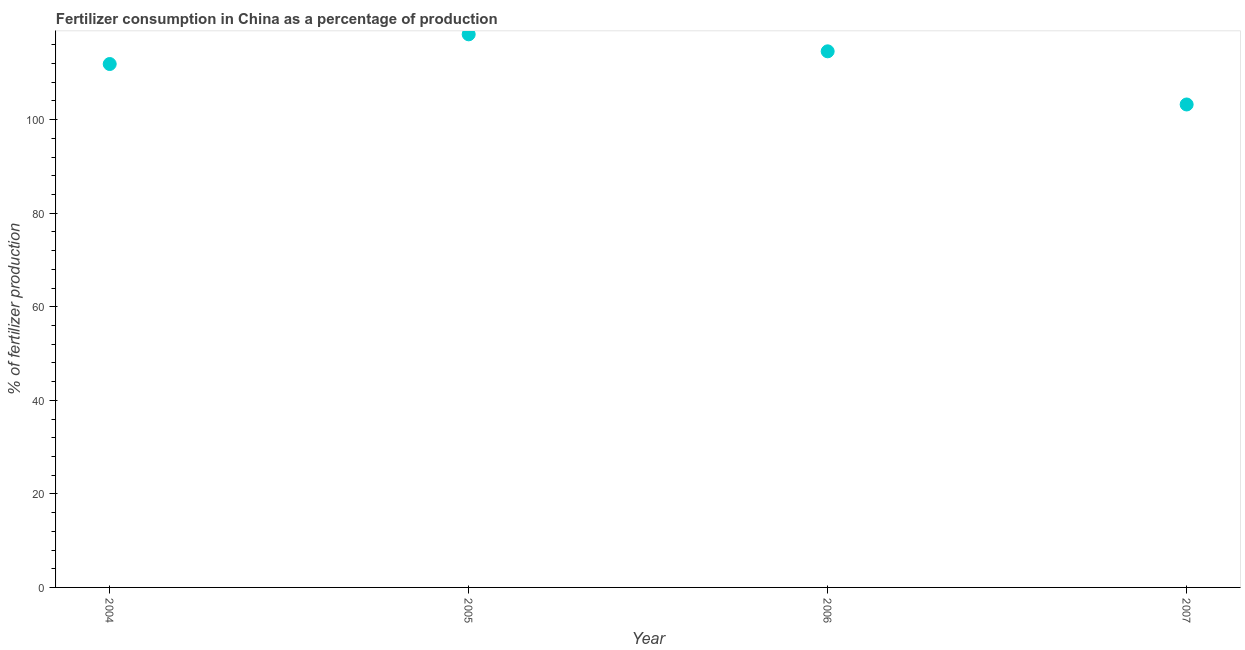What is the amount of fertilizer consumption in 2007?
Provide a succinct answer. 103.23. Across all years, what is the maximum amount of fertilizer consumption?
Your answer should be very brief. 118.23. Across all years, what is the minimum amount of fertilizer consumption?
Keep it short and to the point. 103.23. In which year was the amount of fertilizer consumption maximum?
Ensure brevity in your answer.  2005. In which year was the amount of fertilizer consumption minimum?
Your response must be concise. 2007. What is the sum of the amount of fertilizer consumption?
Keep it short and to the point. 447.94. What is the difference between the amount of fertilizer consumption in 2004 and 2006?
Ensure brevity in your answer.  -2.71. What is the average amount of fertilizer consumption per year?
Provide a succinct answer. 111.98. What is the median amount of fertilizer consumption?
Make the answer very short. 113.24. What is the ratio of the amount of fertilizer consumption in 2004 to that in 2006?
Your response must be concise. 0.98. Is the amount of fertilizer consumption in 2004 less than that in 2006?
Your answer should be very brief. Yes. What is the difference between the highest and the second highest amount of fertilizer consumption?
Keep it short and to the point. 3.63. Is the sum of the amount of fertilizer consumption in 2004 and 2006 greater than the maximum amount of fertilizer consumption across all years?
Ensure brevity in your answer.  Yes. What is the difference between the highest and the lowest amount of fertilizer consumption?
Offer a very short reply. 14.99. How many dotlines are there?
Provide a short and direct response. 1. What is the difference between two consecutive major ticks on the Y-axis?
Provide a succinct answer. 20. Does the graph contain grids?
Keep it short and to the point. No. What is the title of the graph?
Keep it short and to the point. Fertilizer consumption in China as a percentage of production. What is the label or title of the Y-axis?
Provide a short and direct response. % of fertilizer production. What is the % of fertilizer production in 2004?
Provide a short and direct response. 111.88. What is the % of fertilizer production in 2005?
Your answer should be very brief. 118.23. What is the % of fertilizer production in 2006?
Keep it short and to the point. 114.6. What is the % of fertilizer production in 2007?
Your answer should be compact. 103.23. What is the difference between the % of fertilizer production in 2004 and 2005?
Your answer should be very brief. -6.35. What is the difference between the % of fertilizer production in 2004 and 2006?
Keep it short and to the point. -2.71. What is the difference between the % of fertilizer production in 2004 and 2007?
Offer a terse response. 8.65. What is the difference between the % of fertilizer production in 2005 and 2006?
Your response must be concise. 3.63. What is the difference between the % of fertilizer production in 2005 and 2007?
Keep it short and to the point. 14.99. What is the difference between the % of fertilizer production in 2006 and 2007?
Your answer should be very brief. 11.36. What is the ratio of the % of fertilizer production in 2004 to that in 2005?
Ensure brevity in your answer.  0.95. What is the ratio of the % of fertilizer production in 2004 to that in 2006?
Provide a succinct answer. 0.98. What is the ratio of the % of fertilizer production in 2004 to that in 2007?
Offer a terse response. 1.08. What is the ratio of the % of fertilizer production in 2005 to that in 2006?
Your answer should be compact. 1.03. What is the ratio of the % of fertilizer production in 2005 to that in 2007?
Your response must be concise. 1.15. What is the ratio of the % of fertilizer production in 2006 to that in 2007?
Your response must be concise. 1.11. 